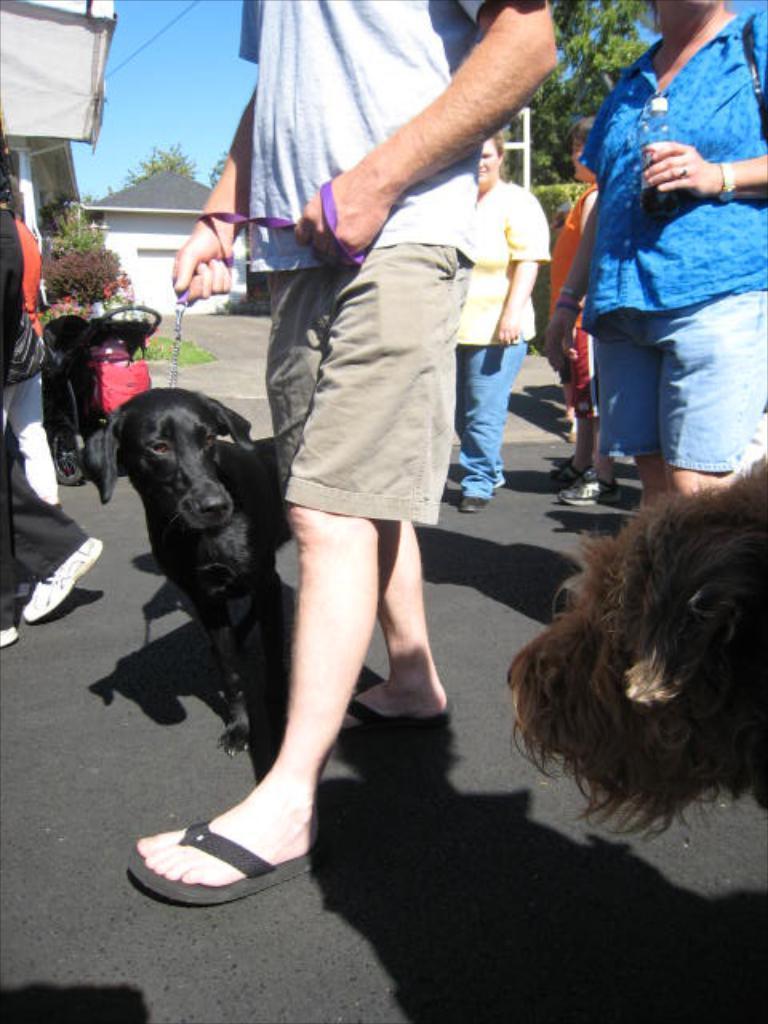In one or two sentences, can you explain what this image depicts? In this picture we can see a group of people walking on road, dogs with them and in background we can see houses, trees,sky, wires, stroller. 